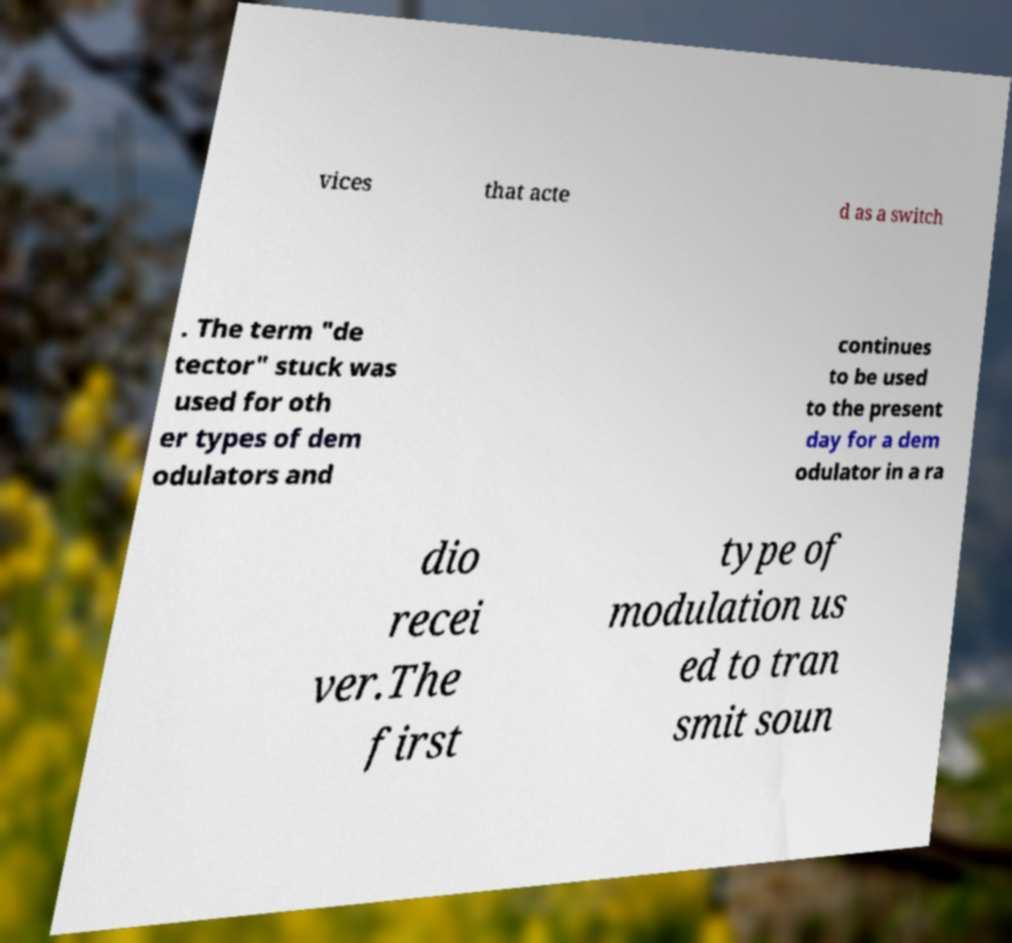Can you accurately transcribe the text from the provided image for me? vices that acte d as a switch . The term "de tector" stuck was used for oth er types of dem odulators and continues to be used to the present day for a dem odulator in a ra dio recei ver.The first type of modulation us ed to tran smit soun 